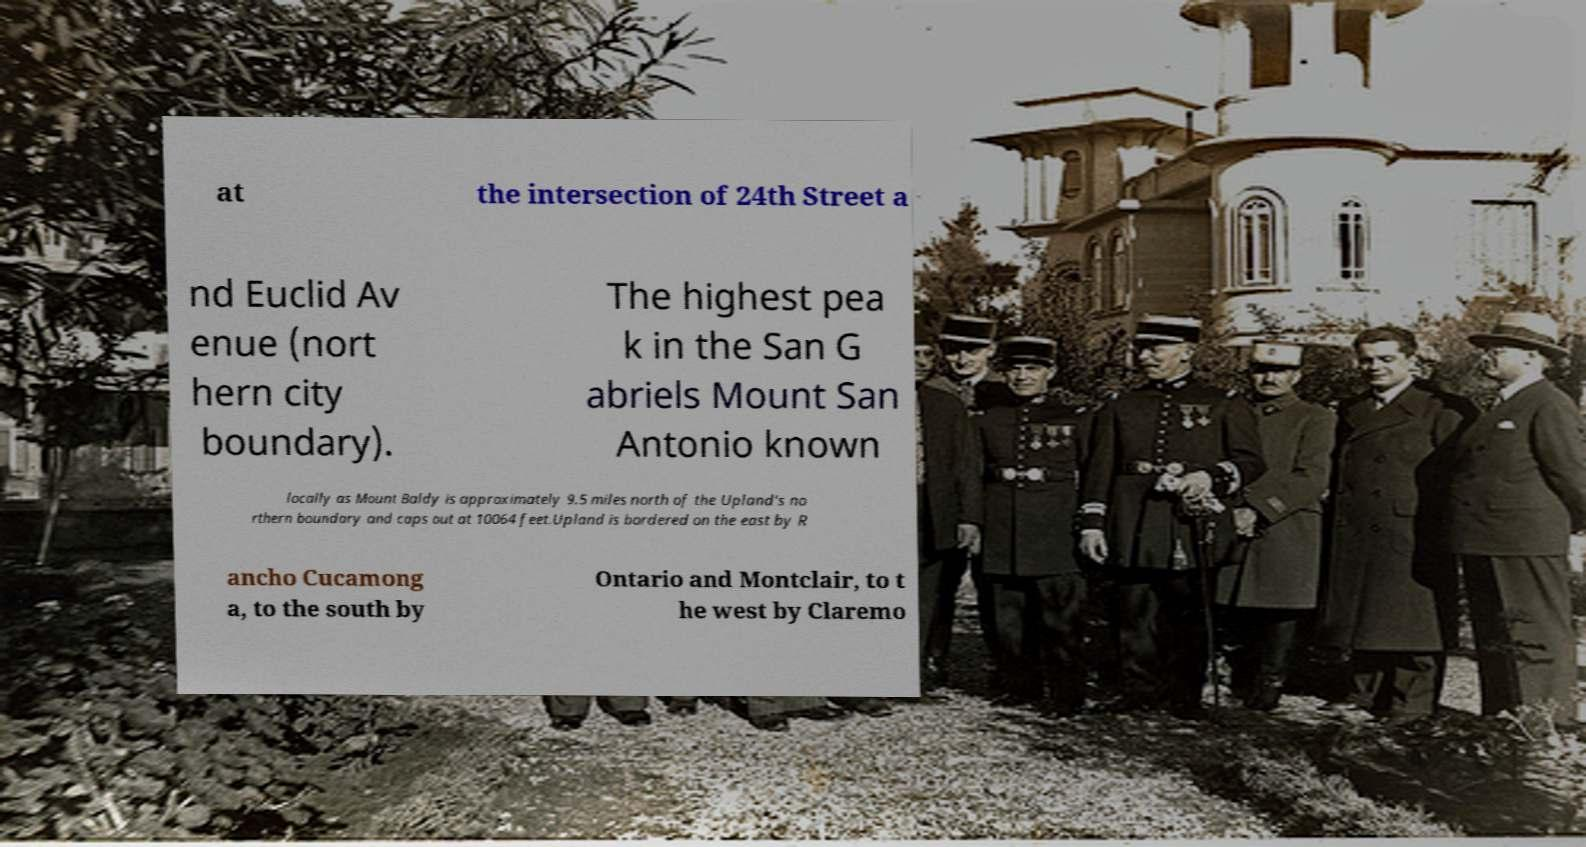I need the written content from this picture converted into text. Can you do that? at the intersection of 24th Street a nd Euclid Av enue (nort hern city boundary). The highest pea k in the San G abriels Mount San Antonio known locally as Mount Baldy is approximately 9.5 miles north of the Upland's no rthern boundary and caps out at 10064 feet.Upland is bordered on the east by R ancho Cucamong a, to the south by Ontario and Montclair, to t he west by Claremo 